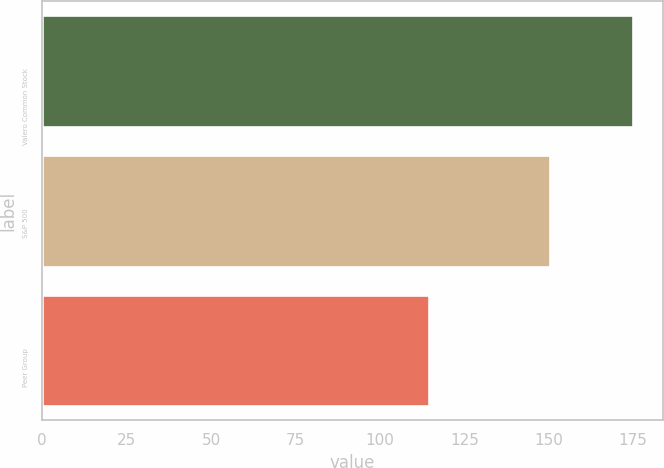Convert chart. <chart><loc_0><loc_0><loc_500><loc_500><bar_chart><fcel>Valero Common Stock<fcel>S&P 500<fcel>Peer Group<nl><fcel>174.97<fcel>150.33<fcel>114.59<nl></chart> 